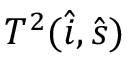<formula> <loc_0><loc_0><loc_500><loc_500>T ^ { 2 } ( \hat { i } , \hat { s } )</formula> 